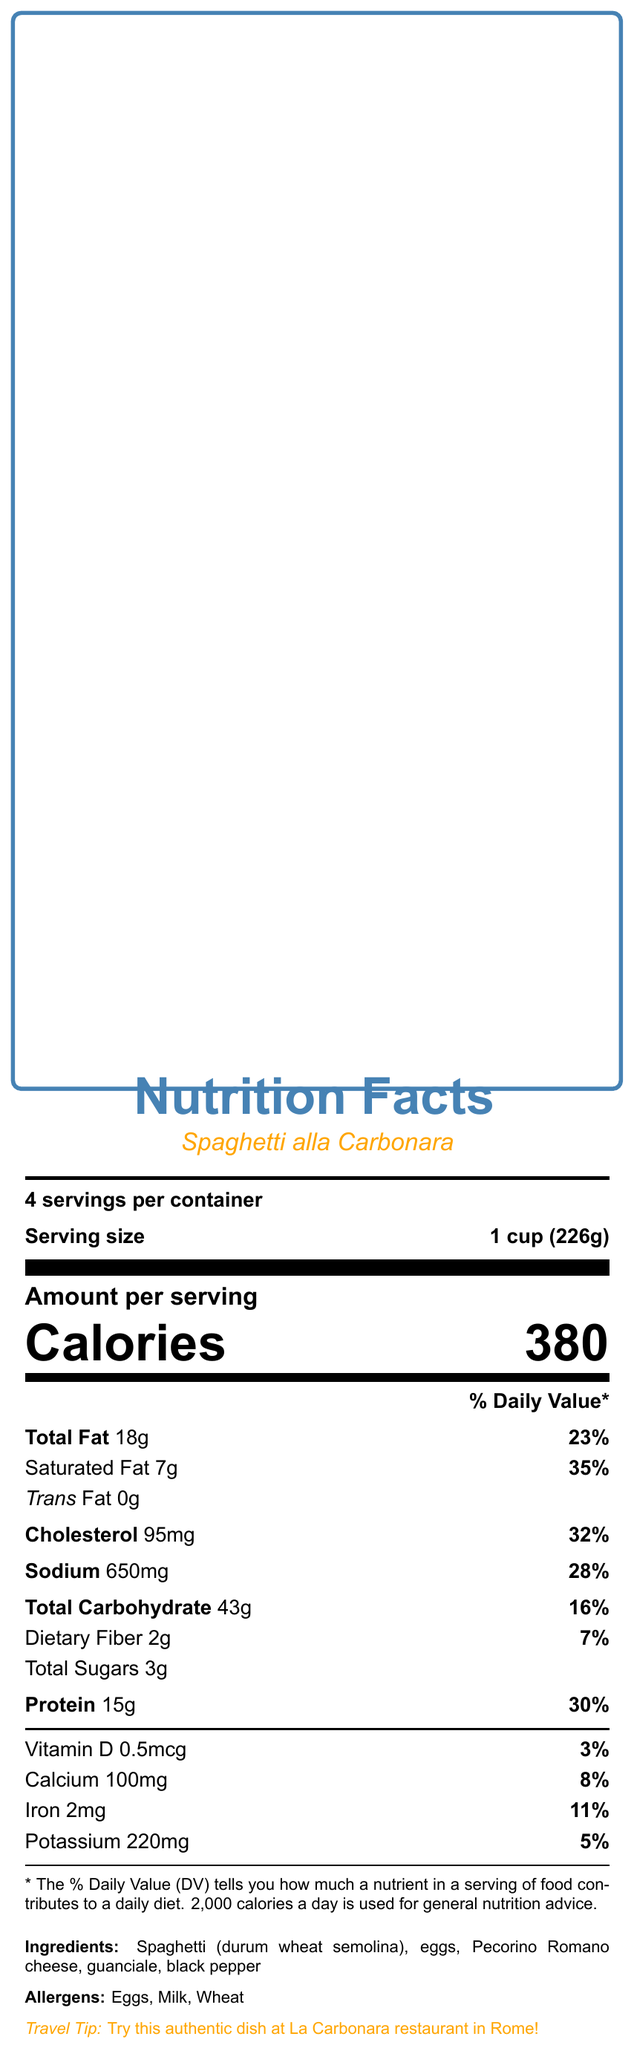what is the serving size for Spaghetti alla Carbonara? The document mentions that the serving size for Spaghetti alla Carbonara is 1 cup (226g).
Answer: 1 cup (226g) How many calories are in one serving of Gluten-Free Spaghetti alla Carbonara? The document states that the Gluten-Free Spaghetti alla Carbonara has 360 calories per serving.
Answer: 360 Which dish has more dietary fiber, the traditional Spaghetti alla Carbonara or the gluten-free version? The document shows that the Gluten-Free Spaghetti alla Carbonara has 3g of dietary fiber, while the traditional version has 2g.
Answer: Gluten-Free Spaghetti alla Carbonara What is the total amount of fat in the traditional Spaghetti alla Carbonara? The document lists the total fat content for the traditional Spaghetti alla Carbonara as 18g.
Answer: 18g What are the allergens in the traditional Spaghetti alla Carbonara? The document specifies that the allergens in the traditional Spaghetti alla Carbonara include Eggs, Milk, and Wheat.
Answer: Eggs, Milk, Wheat Which pasta contains more protein per serving? The document shows that the traditional Spaghetti alla Carbonara has 15g of protein, while the gluten-free version has 14g.
Answer: Traditional Spaghetti alla Carbonara What percentage of the Daily Value of cholesterol does the Gluten-Free Spaghetti alla Carbonara provide? A. 27% B. 32% C. 28% D. 35% Both the traditional and gluten-free versions contain 95mg of cholesterol, which is 32% of the Daily Value.
Answer: B. 32% Which version of Spaghetti alla Carbonara has more calcium? A. Traditional version B. Gluten-Free version C. Both have the same amount D. Cannot be determined The document states that the traditional version has 100mg of calcium, while the gluten-free version has 80mg.
Answer: A. Traditional version Does the traditional Spaghetti alla Carbonara contain more sodium than the gluten-free version? The document shows that the traditional version contains 650mg of sodium, whereas the gluten-free version contains 630mg.
Answer: Yes Summarize the main differences between the traditional and gluten-free versions of Spaghetti alla Carbonara. This summary reflects the key nutritional differences between both versions based on the information provided.
Answer: The traditional Spaghetti alla Carbonara has higher calories, total fat, and calcium content compared to its gluten-free counterpart. The gluten-free version has higher dietary fiber. Both versions have identical serving sizes, cholesterol, saturated fat, trans fat, and vitamin D content. What is the origin of the Spaghetti alla Carbonara dish? The document explicitly states that Spaghetti alla Carbonara originates from Rome, Italy.
Answer: Rome, Italy Which dish has more potassium, the traditional or the gluten-free version? The document indicates that the traditional version has 220mg of potassium, while the gluten-free version has 200mg.
Answer: Traditional Spaghetti alla Carbonara What is the preparation time of the Spaghetti alla Carbonara dish? The document mentions that the preparation time for Spaghetti alla Carbonara is 20 minutes.
Answer: 20 minutes How much saturated fat is in one serving of the gluten-free version? The document shows that the gluten-free Spaghetti alla Carbonara contains 7g of saturated fat per serving.
Answer: 7g What are the popular gluten-free pasta brands mentioned in the document? The document lists these brands under additional information for the gluten-free version.
Answer: Barilla, Jovial, Banza, Tinkyada Does the traditional version of Spaghetti alla Carbonara contain any trans fat? The document clearly states that the trans fat content in the traditional version is 0g.
Answer: No Can the gluten-free Spaghetti alla Carbonara be prepared without pecorino romano cheese? The document does not provide enough information on whether the pecorino romano cheese can be omitted in the gluten-free version.
Answer: Not enough information What is the flavor profile of Spaghetti alla Carbonara? According to the document, the described flavor profile is rich, savory, with a hint of black pepper.
Answer: Rich, savory, with a hint of black pepper 